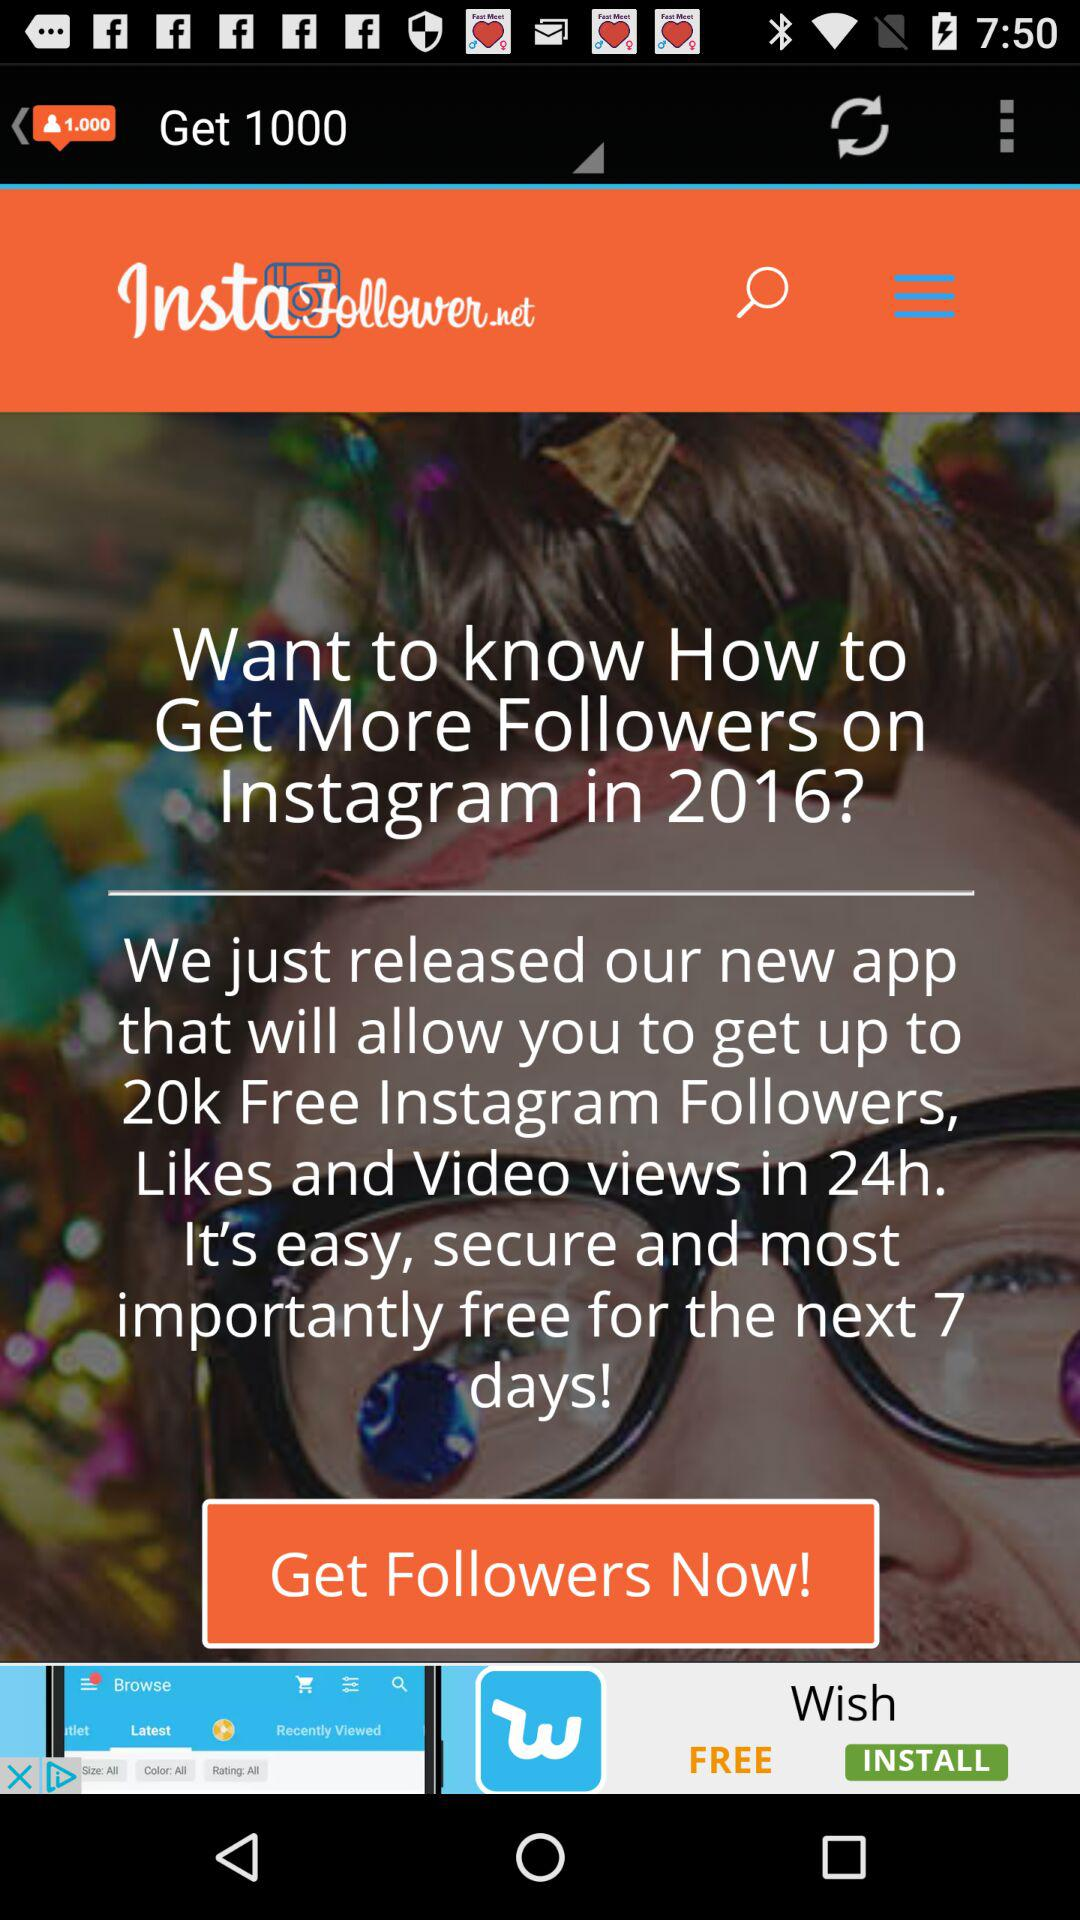What is the name of the application? The name of the application is "InstaFollower.net". 